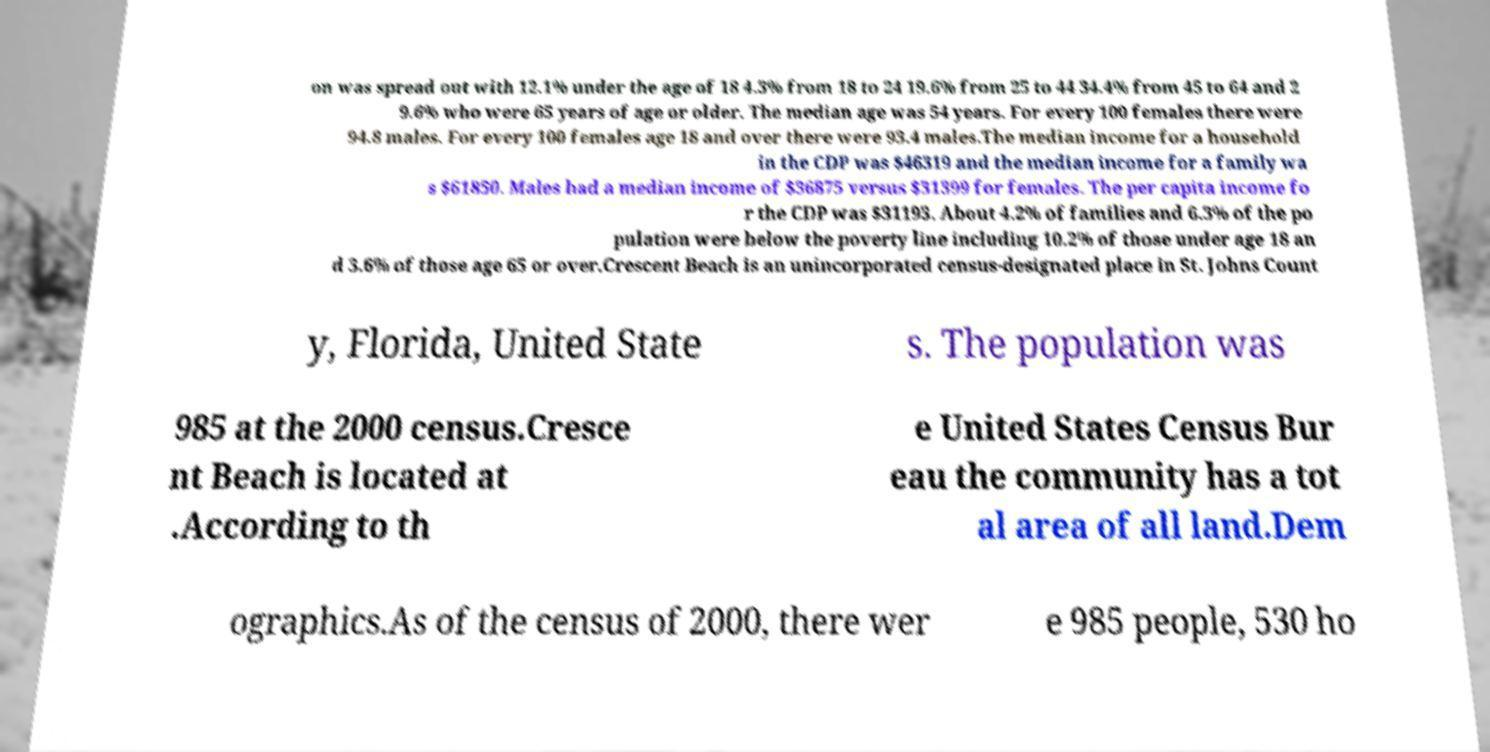Can you accurately transcribe the text from the provided image for me? on was spread out with 12.1% under the age of 18 4.3% from 18 to 24 19.6% from 25 to 44 34.4% from 45 to 64 and 2 9.6% who were 65 years of age or older. The median age was 54 years. For every 100 females there were 94.8 males. For every 100 females age 18 and over there were 93.4 males.The median income for a household in the CDP was $46319 and the median income for a family wa s $61850. Males had a median income of $36875 versus $31399 for females. The per capita income fo r the CDP was $31193. About 4.2% of families and 6.3% of the po pulation were below the poverty line including 10.2% of those under age 18 an d 3.6% of those age 65 or over.Crescent Beach is an unincorporated census-designated place in St. Johns Count y, Florida, United State s. The population was 985 at the 2000 census.Cresce nt Beach is located at .According to th e United States Census Bur eau the community has a tot al area of all land.Dem ographics.As of the census of 2000, there wer e 985 people, 530 ho 